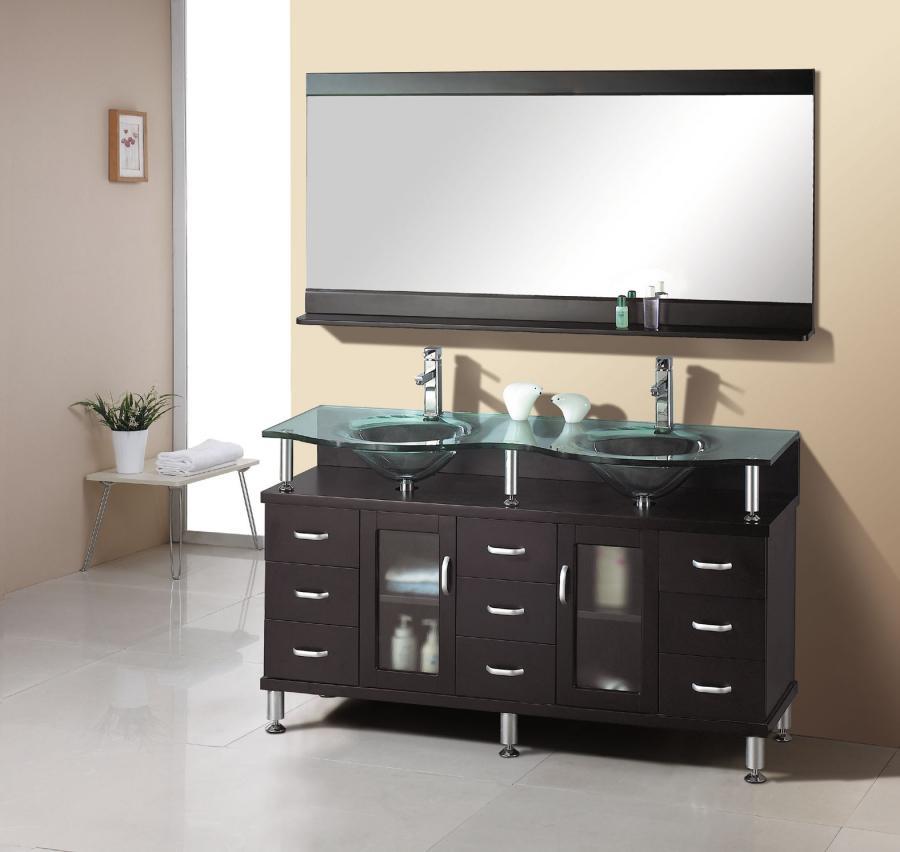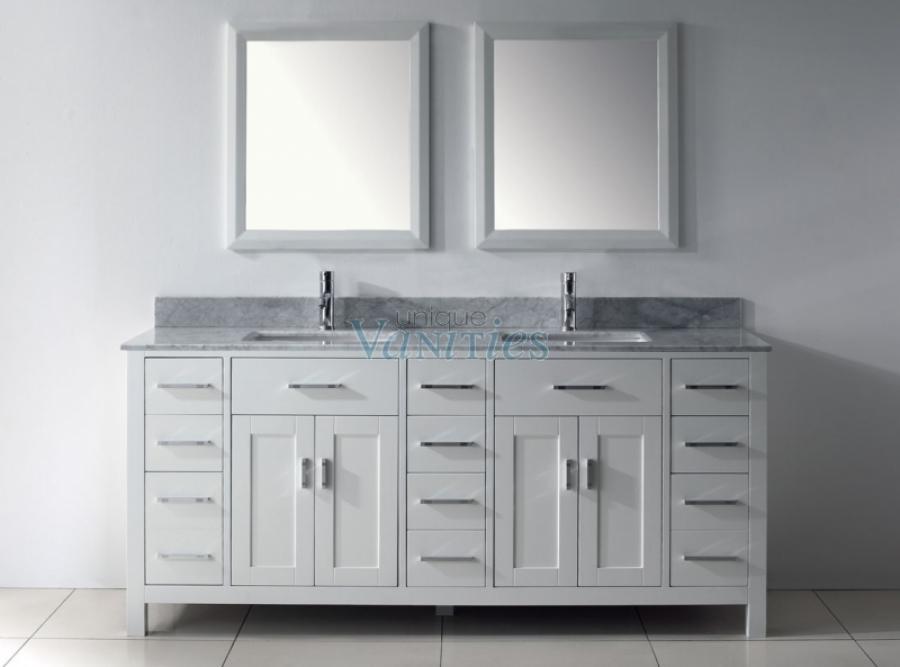The first image is the image on the left, the second image is the image on the right. Considering the images on both sides, is "At least one image shows a pair of mirrors over a double vanity with the bottom of its cabinet open and holding towels." valid? Answer yes or no. No. The first image is the image on the left, the second image is the image on the right. Given the left and right images, does the statement "One of the sink vanities does not have a double mirror above it." hold true? Answer yes or no. Yes. 